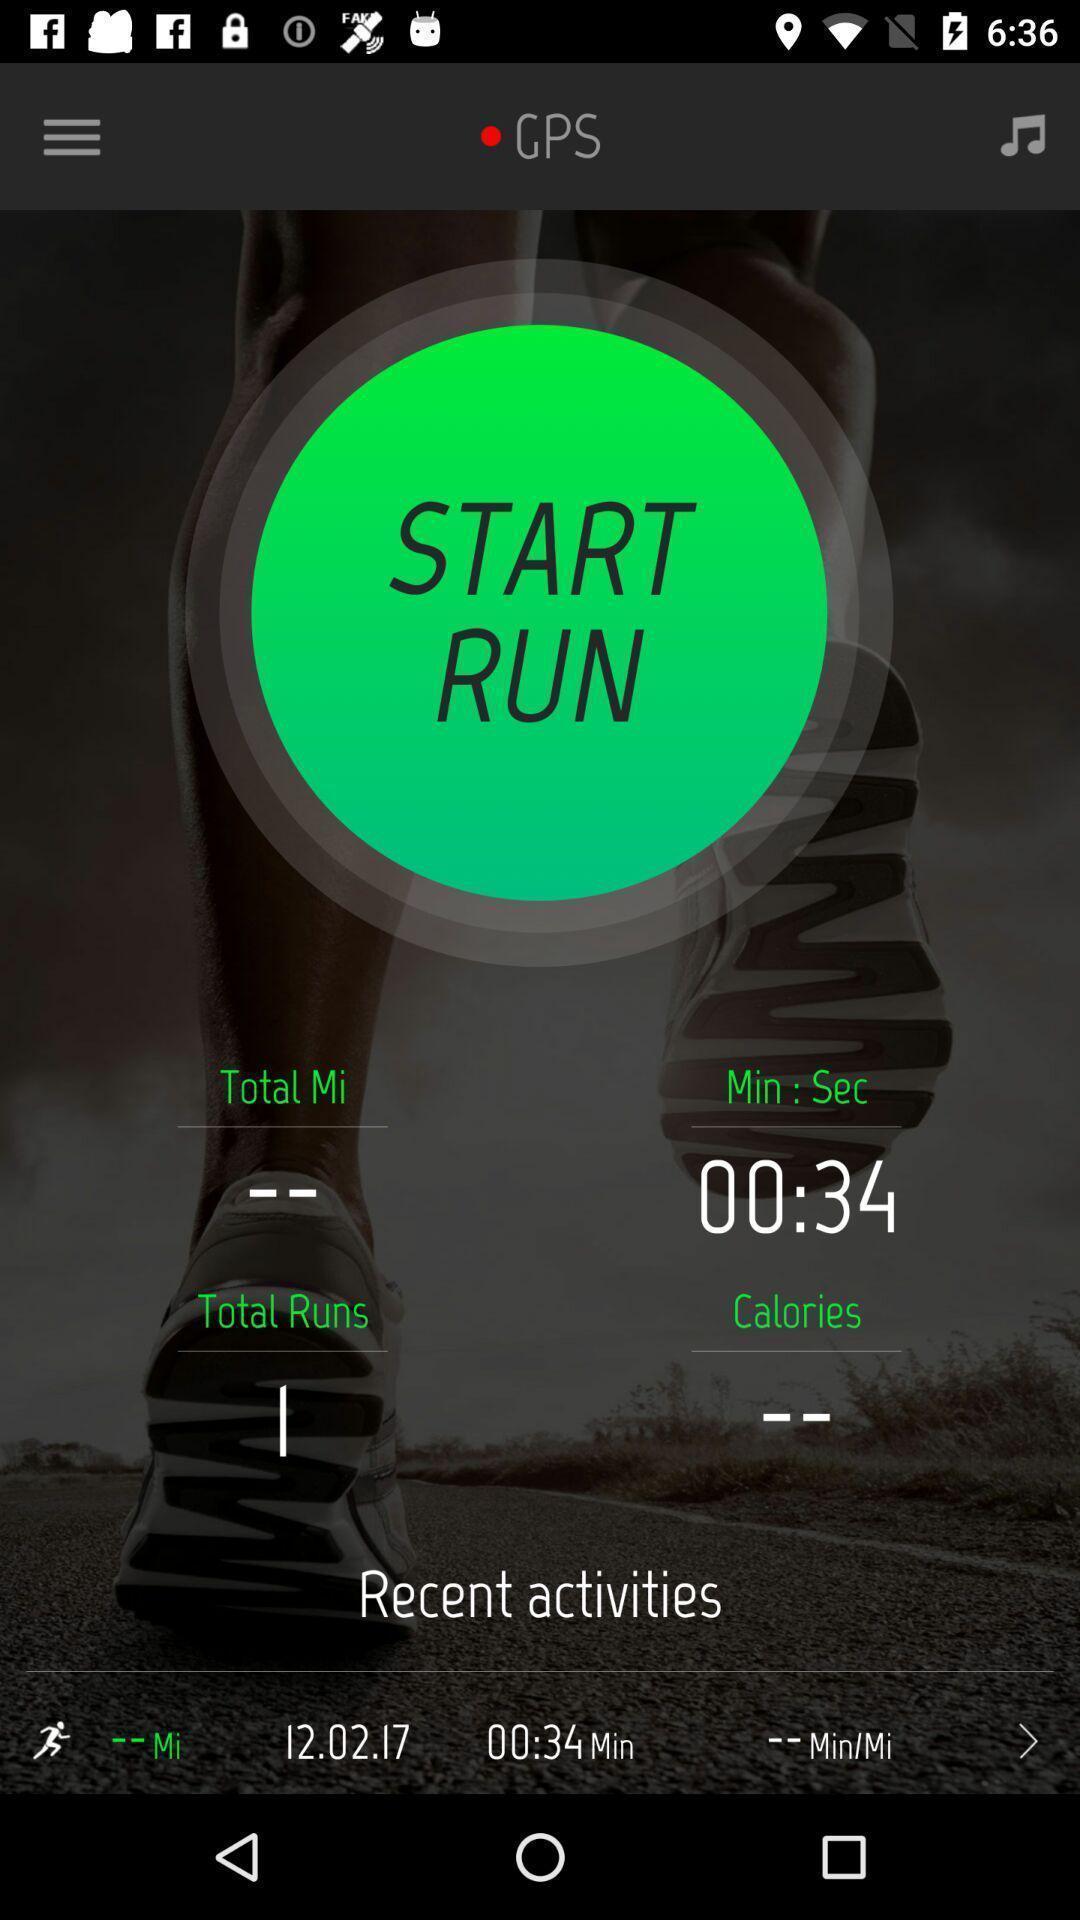Describe the visual elements of this screenshot. Page showing recent activities information with music icon. 